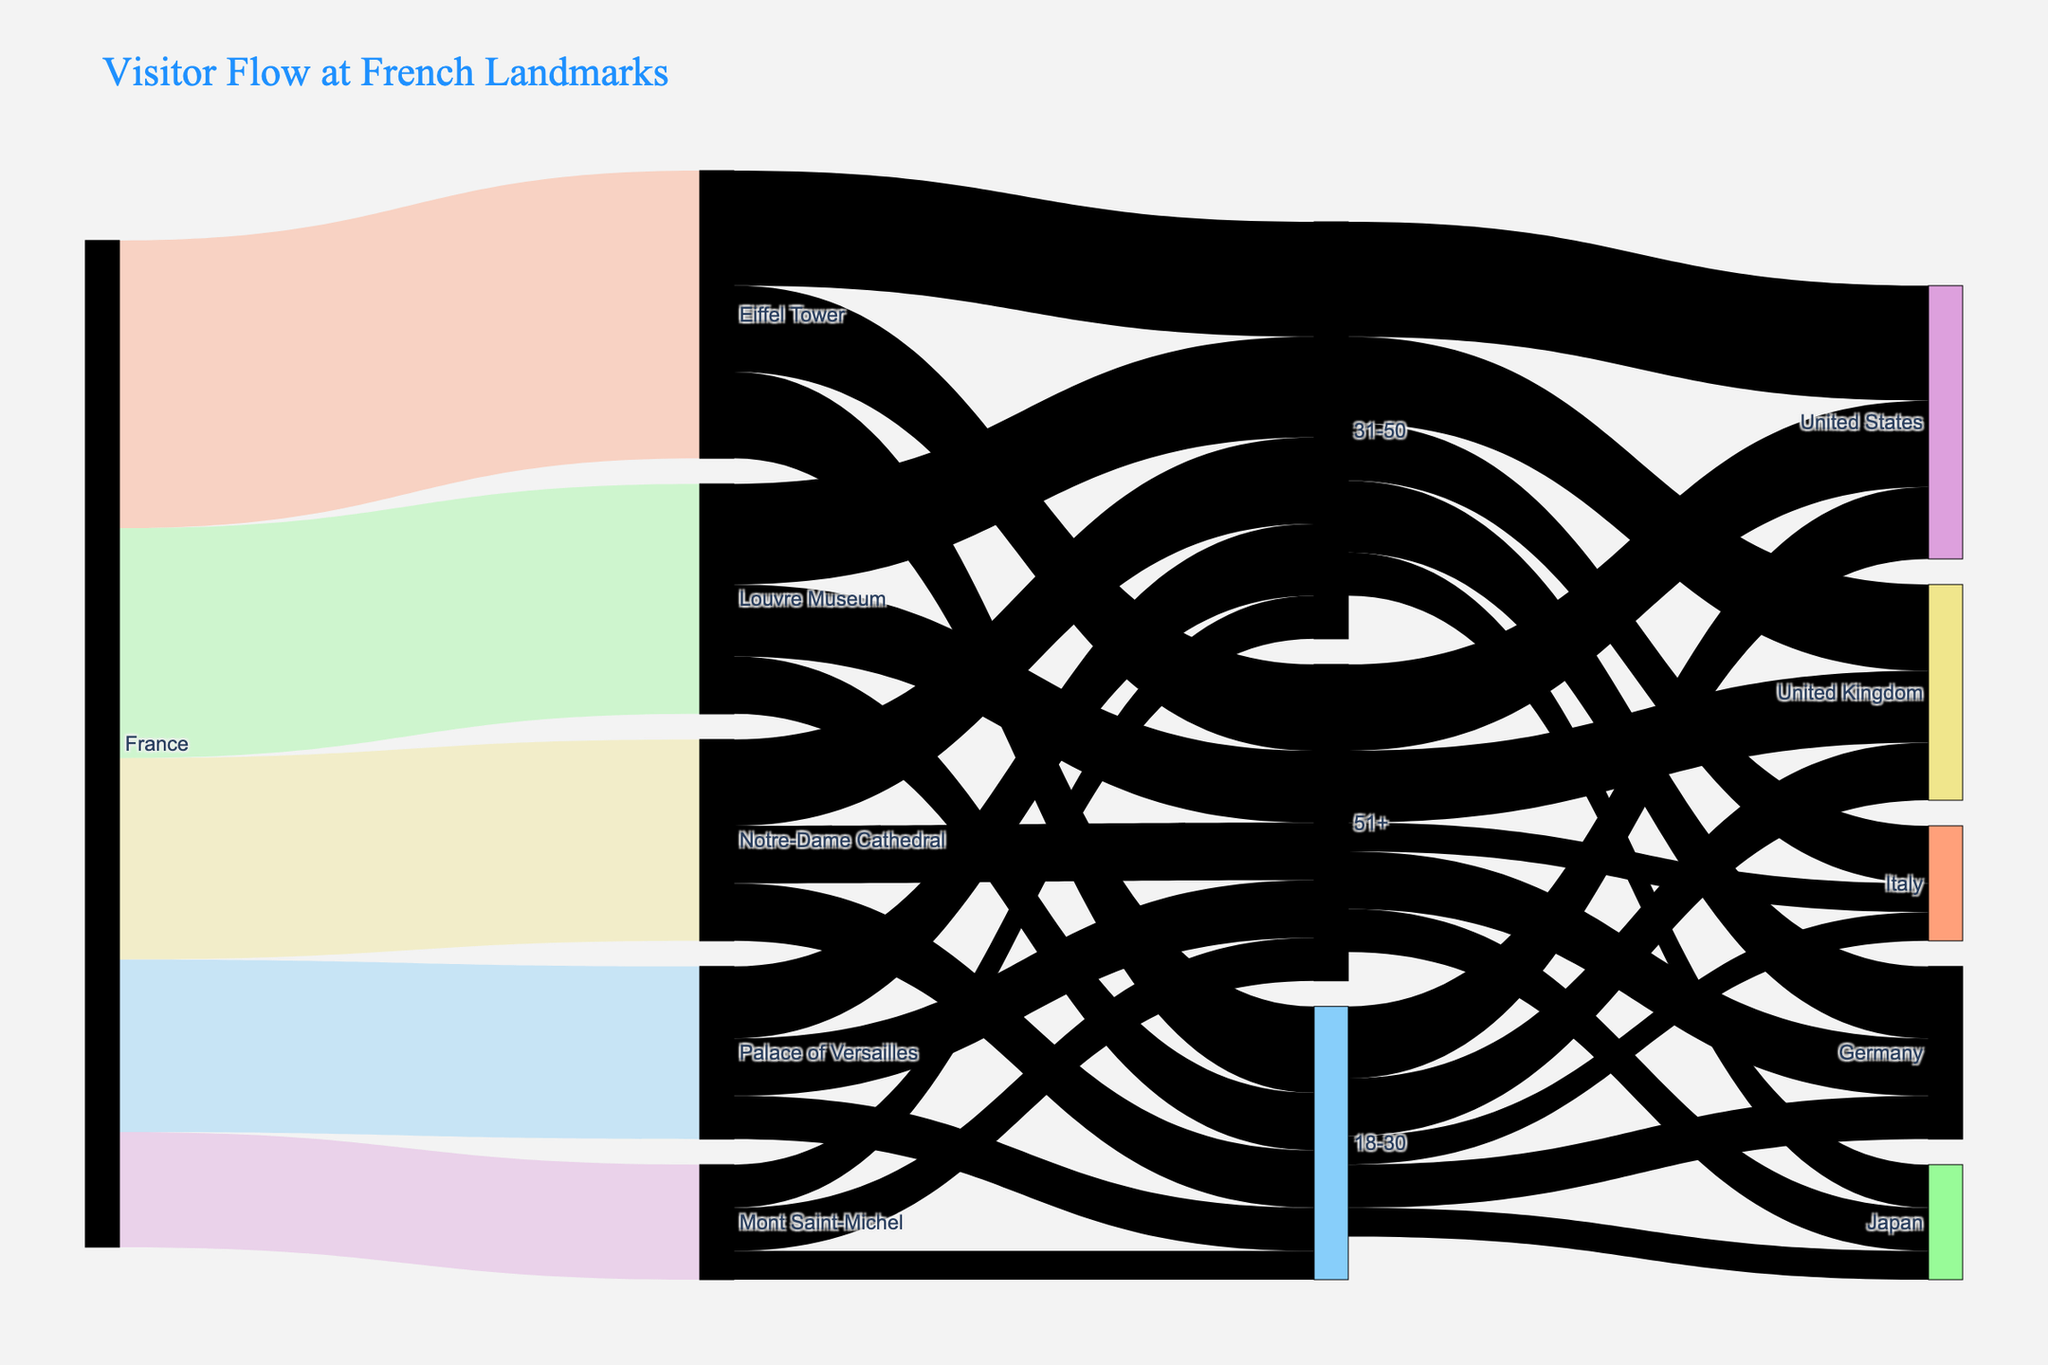Which landmark receives the most visitors? To determine this, observe the width of the lines leading to each landmark from the 'France' node. The thickest line represents the most visitors. The Eiffel Tower has the widest line from 'France'.
Answer: Eiffel Tower What is the total number of visitors aged 31-50 to all landmarks? Add the number of visitors aged 31-50 for each landmark. This includes: Eiffel Tower (400,000), Louvre Museum (350,000), Palace of Versailles (250,000), Mont Saint-Michel (150,000), and Notre-Dame Cathedral (300,000). Total = 400,000 + 350,000 + 250,000 + 150,000 + 300,000 = 1,450,000.
Answer: 1,450,000 How many visitors come from the United States in the age group 51+? Check the lines connecting the '51+' node to the 'United States' node and read the value. For age group 51+, the United States has 300,000 visitors.
Answer: 300,000 Which age group has more visitors to the Palace of Versailles: 18-30 or 51+? Compare the values for the age groups 18-30 and 51+ going to the Palace of Versailles. 18-30 has 150,000 visitors, and 51+ has 200,000 visitors.
Answer: 51+ What is the total number of visitors to the Louvre Museum from all age groups? Sum the number of visitors to the Louvre Museum for each age group. This includes: 18-30 (200,000), 31-50 (350,000), and 51+ (250,000). Total = 200,000 + 350,000 + 250,000 = 800,000.
Answer: 800,000 Which landmark has the fewest visitors from all age groups? Determine which landmark node has the thinnest combined line widths for all age groups. Mont Saint-Michel has the thinnest combined lines.
Answer: Mont Saint-Michel How many visitors from the United Kingdom are in the 18-30 age group? Check the link from the '18-30' node to the 'United Kingdom' node and read the value. The value is 200,000 visitors.
Answer: 200,000 Do more visitors aged 31-50 go to the Eiffel Tower or the Louvre Museum? Compare the values for the 31-50 age group for both landmarks. Eiffel Tower has 400,000 visitors, and Louvre Museum has 350,000 visitors aged 31-50.
Answer: Eiffel Tower What is the age group of visitors most commonly seen at Notre-Dame Cathedral? Identify the widest link emanating from the Notre-Dame Cathedral node. The 31-50 age group has the widest link, indicating the highest number of visitors.
Answer: 31-50 